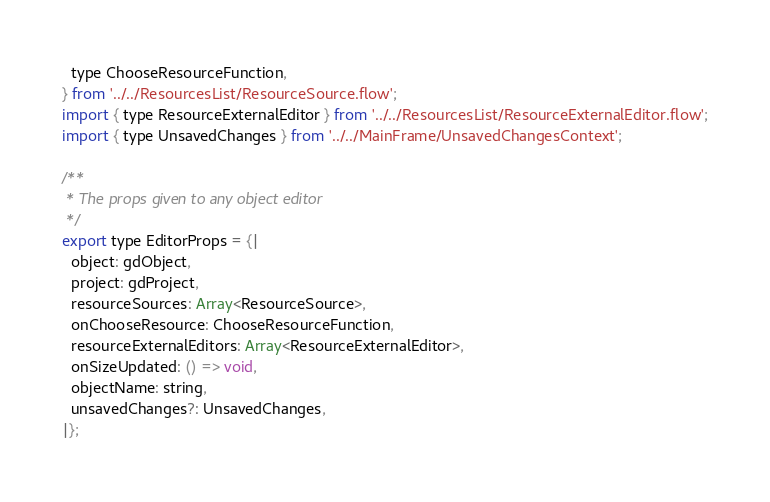<code> <loc_0><loc_0><loc_500><loc_500><_JavaScript_>  type ChooseResourceFunction,
} from '../../ResourcesList/ResourceSource.flow';
import { type ResourceExternalEditor } from '../../ResourcesList/ResourceExternalEditor.flow';
import { type UnsavedChanges } from '../../MainFrame/UnsavedChangesContext';

/**
 * The props given to any object editor
 */
export type EditorProps = {|
  object: gdObject,
  project: gdProject,
  resourceSources: Array<ResourceSource>,
  onChooseResource: ChooseResourceFunction,
  resourceExternalEditors: Array<ResourceExternalEditor>,
  onSizeUpdated: () => void,
  objectName: string,
  unsavedChanges?: UnsavedChanges,
|};
</code> 